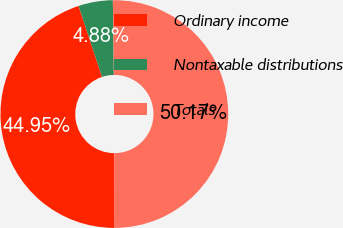Convert chart. <chart><loc_0><loc_0><loc_500><loc_500><pie_chart><fcel>Ordinary income<fcel>Nontaxable distributions<fcel>Totals<nl><fcel>44.95%<fcel>4.88%<fcel>50.17%<nl></chart> 